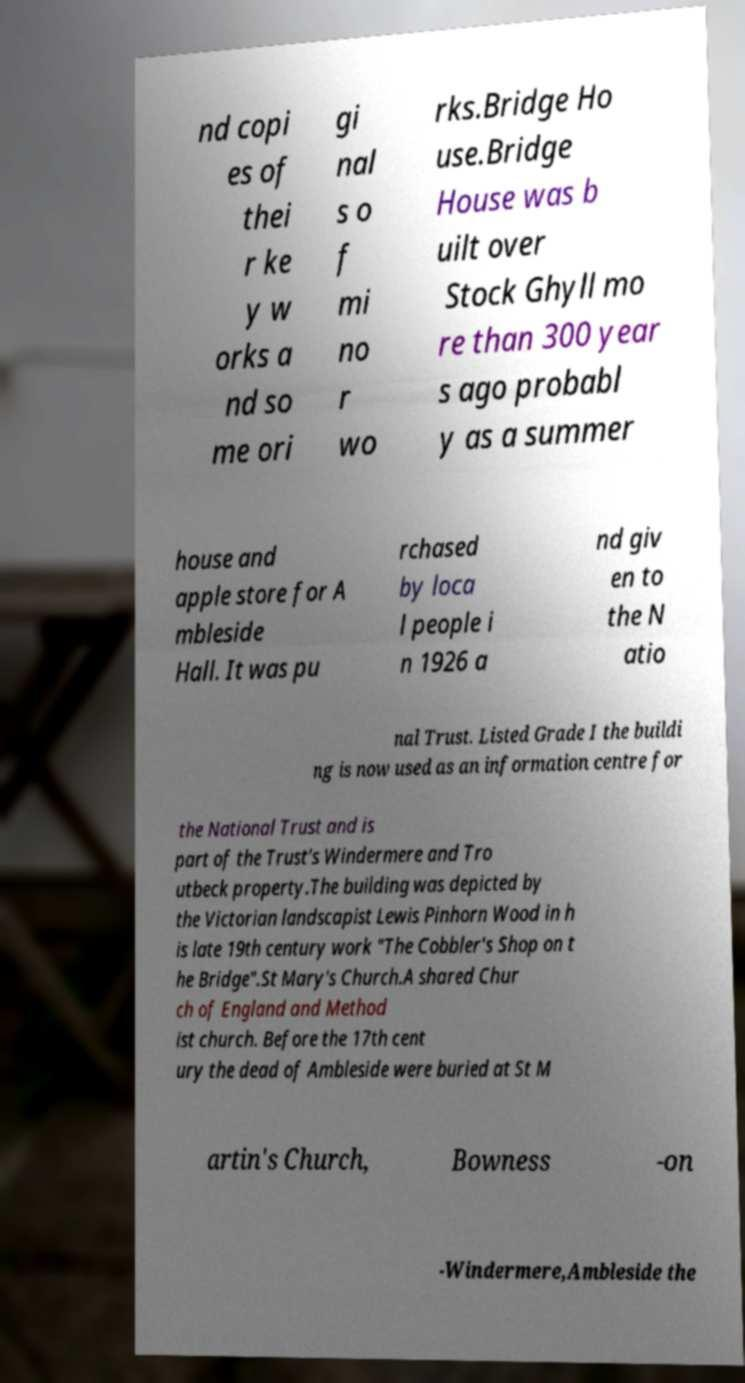I need the written content from this picture converted into text. Can you do that? nd copi es of thei r ke y w orks a nd so me ori gi nal s o f mi no r wo rks.Bridge Ho use.Bridge House was b uilt over Stock Ghyll mo re than 300 year s ago probabl y as a summer house and apple store for A mbleside Hall. It was pu rchased by loca l people i n 1926 a nd giv en to the N atio nal Trust. Listed Grade I the buildi ng is now used as an information centre for the National Trust and is part of the Trust's Windermere and Tro utbeck property.The building was depicted by the Victorian landscapist Lewis Pinhorn Wood in h is late 19th century work "The Cobbler's Shop on t he Bridge".St Mary's Church.A shared Chur ch of England and Method ist church. Before the 17th cent ury the dead of Ambleside were buried at St M artin's Church, Bowness -on -Windermere,Ambleside the 